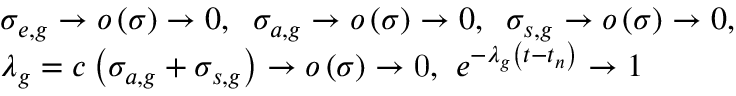Convert formula to latex. <formula><loc_0><loc_0><loc_500><loc_500>\begin{array} { l } { { \sigma _ { e , g } \to o \left ( \sigma \right ) \to 0 , \, \sigma _ { a , g } \to o \left ( \sigma \right ) \to 0 , \, \sigma _ { s , g } \to o \left ( \sigma \right ) \to 0 , } } \\ { { \lambda _ { g } = c \left ( \sigma _ { a , g } + \sigma _ { s , g } \right ) \to o \left ( \sigma \right ) \to 0 , \, e ^ { - \lambda _ { g } \left ( t - t _ { n } \right ) } \to 1 } } \end{array}</formula> 